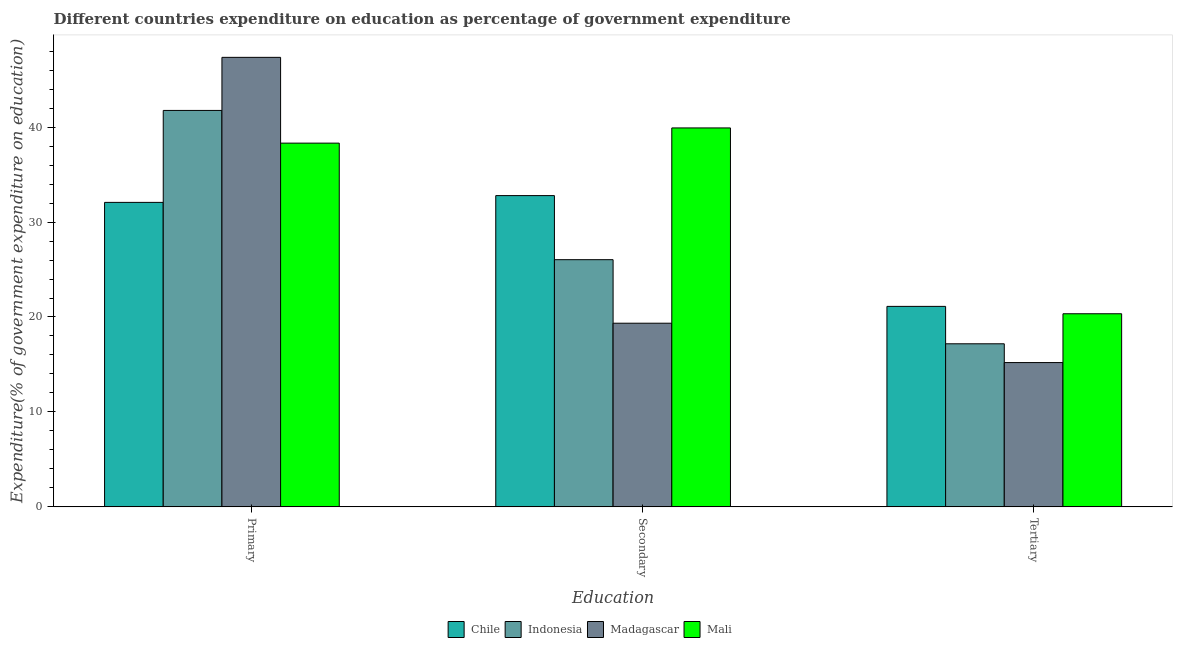How many groups of bars are there?
Give a very brief answer. 3. Are the number of bars per tick equal to the number of legend labels?
Provide a short and direct response. Yes. Are the number of bars on each tick of the X-axis equal?
Provide a succinct answer. Yes. What is the label of the 3rd group of bars from the left?
Your answer should be very brief. Tertiary. What is the expenditure on primary education in Chile?
Offer a very short reply. 32.07. Across all countries, what is the maximum expenditure on tertiary education?
Your answer should be very brief. 21.12. Across all countries, what is the minimum expenditure on secondary education?
Keep it short and to the point. 19.34. In which country was the expenditure on tertiary education minimum?
Your response must be concise. Madagascar. What is the total expenditure on primary education in the graph?
Provide a succinct answer. 159.5. What is the difference between the expenditure on primary education in Mali and that in Madagascar?
Provide a succinct answer. -9.04. What is the difference between the expenditure on primary education in Indonesia and the expenditure on secondary education in Mali?
Make the answer very short. 1.84. What is the average expenditure on primary education per country?
Make the answer very short. 39.88. What is the difference between the expenditure on tertiary education and expenditure on primary education in Madagascar?
Provide a succinct answer. -32.15. In how many countries, is the expenditure on primary education greater than 46 %?
Your answer should be compact. 1. What is the ratio of the expenditure on primary education in Madagascar to that in Indonesia?
Your answer should be compact. 1.13. Is the expenditure on primary education in Madagascar less than that in Indonesia?
Offer a terse response. No. What is the difference between the highest and the second highest expenditure on tertiary education?
Your answer should be very brief. 0.78. What is the difference between the highest and the lowest expenditure on tertiary education?
Provide a succinct answer. 5.92. Is the sum of the expenditure on tertiary education in Chile and Indonesia greater than the maximum expenditure on primary education across all countries?
Ensure brevity in your answer.  No. What does the 3rd bar from the left in Tertiary represents?
Your answer should be compact. Madagascar. What does the 2nd bar from the right in Primary represents?
Offer a very short reply. Madagascar. Is it the case that in every country, the sum of the expenditure on primary education and expenditure on secondary education is greater than the expenditure on tertiary education?
Offer a terse response. Yes. How many bars are there?
Your response must be concise. 12. What is the difference between two consecutive major ticks on the Y-axis?
Offer a very short reply. 10. Are the values on the major ticks of Y-axis written in scientific E-notation?
Make the answer very short. No. Does the graph contain any zero values?
Provide a succinct answer. No. How many legend labels are there?
Your answer should be compact. 4. What is the title of the graph?
Offer a terse response. Different countries expenditure on education as percentage of government expenditure. What is the label or title of the X-axis?
Your answer should be very brief. Education. What is the label or title of the Y-axis?
Provide a succinct answer. Expenditure(% of government expenditure on education). What is the Expenditure(% of government expenditure on education) in Chile in Primary?
Provide a short and direct response. 32.07. What is the Expenditure(% of government expenditure on education) in Indonesia in Primary?
Offer a very short reply. 41.76. What is the Expenditure(% of government expenditure on education) in Madagascar in Primary?
Provide a short and direct response. 47.35. What is the Expenditure(% of government expenditure on education) of Mali in Primary?
Offer a terse response. 38.32. What is the Expenditure(% of government expenditure on education) of Chile in Secondary?
Give a very brief answer. 32.79. What is the Expenditure(% of government expenditure on education) in Indonesia in Secondary?
Your response must be concise. 26.04. What is the Expenditure(% of government expenditure on education) of Madagascar in Secondary?
Keep it short and to the point. 19.34. What is the Expenditure(% of government expenditure on education) in Mali in Secondary?
Offer a very short reply. 39.92. What is the Expenditure(% of government expenditure on education) in Chile in Tertiary?
Your answer should be very brief. 21.12. What is the Expenditure(% of government expenditure on education) of Indonesia in Tertiary?
Your response must be concise. 17.18. What is the Expenditure(% of government expenditure on education) in Madagascar in Tertiary?
Your answer should be compact. 15.2. What is the Expenditure(% of government expenditure on education) of Mali in Tertiary?
Keep it short and to the point. 20.34. Across all Education, what is the maximum Expenditure(% of government expenditure on education) in Chile?
Give a very brief answer. 32.79. Across all Education, what is the maximum Expenditure(% of government expenditure on education) of Indonesia?
Give a very brief answer. 41.76. Across all Education, what is the maximum Expenditure(% of government expenditure on education) of Madagascar?
Keep it short and to the point. 47.35. Across all Education, what is the maximum Expenditure(% of government expenditure on education) of Mali?
Your response must be concise. 39.92. Across all Education, what is the minimum Expenditure(% of government expenditure on education) of Chile?
Make the answer very short. 21.12. Across all Education, what is the minimum Expenditure(% of government expenditure on education) in Indonesia?
Your answer should be very brief. 17.18. Across all Education, what is the minimum Expenditure(% of government expenditure on education) of Madagascar?
Your response must be concise. 15.2. Across all Education, what is the minimum Expenditure(% of government expenditure on education) in Mali?
Your answer should be compact. 20.34. What is the total Expenditure(% of government expenditure on education) of Chile in the graph?
Make the answer very short. 85.98. What is the total Expenditure(% of government expenditure on education) of Indonesia in the graph?
Offer a very short reply. 84.98. What is the total Expenditure(% of government expenditure on education) of Madagascar in the graph?
Give a very brief answer. 81.9. What is the total Expenditure(% of government expenditure on education) of Mali in the graph?
Give a very brief answer. 98.57. What is the difference between the Expenditure(% of government expenditure on education) of Chile in Primary and that in Secondary?
Provide a succinct answer. -0.71. What is the difference between the Expenditure(% of government expenditure on education) of Indonesia in Primary and that in Secondary?
Keep it short and to the point. 15.72. What is the difference between the Expenditure(% of government expenditure on education) in Madagascar in Primary and that in Secondary?
Provide a short and direct response. 28.01. What is the difference between the Expenditure(% of government expenditure on education) in Mali in Primary and that in Secondary?
Offer a terse response. -1.6. What is the difference between the Expenditure(% of government expenditure on education) in Chile in Primary and that in Tertiary?
Your response must be concise. 10.96. What is the difference between the Expenditure(% of government expenditure on education) in Indonesia in Primary and that in Tertiary?
Make the answer very short. 24.58. What is the difference between the Expenditure(% of government expenditure on education) in Madagascar in Primary and that in Tertiary?
Provide a short and direct response. 32.15. What is the difference between the Expenditure(% of government expenditure on education) in Mali in Primary and that in Tertiary?
Your answer should be compact. 17.97. What is the difference between the Expenditure(% of government expenditure on education) of Chile in Secondary and that in Tertiary?
Ensure brevity in your answer.  11.67. What is the difference between the Expenditure(% of government expenditure on education) in Indonesia in Secondary and that in Tertiary?
Offer a terse response. 8.86. What is the difference between the Expenditure(% of government expenditure on education) of Madagascar in Secondary and that in Tertiary?
Provide a short and direct response. 4.15. What is the difference between the Expenditure(% of government expenditure on education) of Mali in Secondary and that in Tertiary?
Your response must be concise. 19.57. What is the difference between the Expenditure(% of government expenditure on education) of Chile in Primary and the Expenditure(% of government expenditure on education) of Indonesia in Secondary?
Provide a short and direct response. 6.04. What is the difference between the Expenditure(% of government expenditure on education) of Chile in Primary and the Expenditure(% of government expenditure on education) of Madagascar in Secondary?
Your answer should be very brief. 12.73. What is the difference between the Expenditure(% of government expenditure on education) in Chile in Primary and the Expenditure(% of government expenditure on education) in Mali in Secondary?
Provide a succinct answer. -7.84. What is the difference between the Expenditure(% of government expenditure on education) of Indonesia in Primary and the Expenditure(% of government expenditure on education) of Madagascar in Secondary?
Provide a succinct answer. 22.42. What is the difference between the Expenditure(% of government expenditure on education) in Indonesia in Primary and the Expenditure(% of government expenditure on education) in Mali in Secondary?
Provide a succinct answer. 1.84. What is the difference between the Expenditure(% of government expenditure on education) in Madagascar in Primary and the Expenditure(% of government expenditure on education) in Mali in Secondary?
Provide a succinct answer. 7.43. What is the difference between the Expenditure(% of government expenditure on education) in Chile in Primary and the Expenditure(% of government expenditure on education) in Indonesia in Tertiary?
Provide a succinct answer. 14.9. What is the difference between the Expenditure(% of government expenditure on education) in Chile in Primary and the Expenditure(% of government expenditure on education) in Madagascar in Tertiary?
Make the answer very short. 16.87. What is the difference between the Expenditure(% of government expenditure on education) in Chile in Primary and the Expenditure(% of government expenditure on education) in Mali in Tertiary?
Keep it short and to the point. 11.73. What is the difference between the Expenditure(% of government expenditure on education) in Indonesia in Primary and the Expenditure(% of government expenditure on education) in Madagascar in Tertiary?
Offer a very short reply. 26.56. What is the difference between the Expenditure(% of government expenditure on education) in Indonesia in Primary and the Expenditure(% of government expenditure on education) in Mali in Tertiary?
Make the answer very short. 21.42. What is the difference between the Expenditure(% of government expenditure on education) in Madagascar in Primary and the Expenditure(% of government expenditure on education) in Mali in Tertiary?
Keep it short and to the point. 27.01. What is the difference between the Expenditure(% of government expenditure on education) in Chile in Secondary and the Expenditure(% of government expenditure on education) in Indonesia in Tertiary?
Give a very brief answer. 15.61. What is the difference between the Expenditure(% of government expenditure on education) in Chile in Secondary and the Expenditure(% of government expenditure on education) in Madagascar in Tertiary?
Ensure brevity in your answer.  17.59. What is the difference between the Expenditure(% of government expenditure on education) in Chile in Secondary and the Expenditure(% of government expenditure on education) in Mali in Tertiary?
Your answer should be very brief. 12.45. What is the difference between the Expenditure(% of government expenditure on education) in Indonesia in Secondary and the Expenditure(% of government expenditure on education) in Madagascar in Tertiary?
Offer a terse response. 10.84. What is the difference between the Expenditure(% of government expenditure on education) in Indonesia in Secondary and the Expenditure(% of government expenditure on education) in Mali in Tertiary?
Keep it short and to the point. 5.7. What is the difference between the Expenditure(% of government expenditure on education) in Madagascar in Secondary and the Expenditure(% of government expenditure on education) in Mali in Tertiary?
Offer a terse response. -1. What is the average Expenditure(% of government expenditure on education) of Chile per Education?
Provide a succinct answer. 28.66. What is the average Expenditure(% of government expenditure on education) of Indonesia per Education?
Keep it short and to the point. 28.33. What is the average Expenditure(% of government expenditure on education) of Madagascar per Education?
Offer a very short reply. 27.3. What is the average Expenditure(% of government expenditure on education) of Mali per Education?
Offer a terse response. 32.86. What is the difference between the Expenditure(% of government expenditure on education) of Chile and Expenditure(% of government expenditure on education) of Indonesia in Primary?
Make the answer very short. -9.69. What is the difference between the Expenditure(% of government expenditure on education) in Chile and Expenditure(% of government expenditure on education) in Madagascar in Primary?
Your answer should be compact. -15.28. What is the difference between the Expenditure(% of government expenditure on education) in Chile and Expenditure(% of government expenditure on education) in Mali in Primary?
Give a very brief answer. -6.24. What is the difference between the Expenditure(% of government expenditure on education) of Indonesia and Expenditure(% of government expenditure on education) of Madagascar in Primary?
Keep it short and to the point. -5.59. What is the difference between the Expenditure(% of government expenditure on education) in Indonesia and Expenditure(% of government expenditure on education) in Mali in Primary?
Make the answer very short. 3.45. What is the difference between the Expenditure(% of government expenditure on education) of Madagascar and Expenditure(% of government expenditure on education) of Mali in Primary?
Make the answer very short. 9.04. What is the difference between the Expenditure(% of government expenditure on education) in Chile and Expenditure(% of government expenditure on education) in Indonesia in Secondary?
Offer a terse response. 6.75. What is the difference between the Expenditure(% of government expenditure on education) in Chile and Expenditure(% of government expenditure on education) in Madagascar in Secondary?
Ensure brevity in your answer.  13.44. What is the difference between the Expenditure(% of government expenditure on education) of Chile and Expenditure(% of government expenditure on education) of Mali in Secondary?
Your answer should be compact. -7.13. What is the difference between the Expenditure(% of government expenditure on education) of Indonesia and Expenditure(% of government expenditure on education) of Madagascar in Secondary?
Offer a terse response. 6.69. What is the difference between the Expenditure(% of government expenditure on education) in Indonesia and Expenditure(% of government expenditure on education) in Mali in Secondary?
Your answer should be very brief. -13.88. What is the difference between the Expenditure(% of government expenditure on education) in Madagascar and Expenditure(% of government expenditure on education) in Mali in Secondary?
Provide a short and direct response. -20.57. What is the difference between the Expenditure(% of government expenditure on education) in Chile and Expenditure(% of government expenditure on education) in Indonesia in Tertiary?
Your answer should be very brief. 3.94. What is the difference between the Expenditure(% of government expenditure on education) of Chile and Expenditure(% of government expenditure on education) of Madagascar in Tertiary?
Your response must be concise. 5.92. What is the difference between the Expenditure(% of government expenditure on education) in Chile and Expenditure(% of government expenditure on education) in Mali in Tertiary?
Your response must be concise. 0.78. What is the difference between the Expenditure(% of government expenditure on education) in Indonesia and Expenditure(% of government expenditure on education) in Madagascar in Tertiary?
Keep it short and to the point. 1.98. What is the difference between the Expenditure(% of government expenditure on education) of Indonesia and Expenditure(% of government expenditure on education) of Mali in Tertiary?
Ensure brevity in your answer.  -3.16. What is the difference between the Expenditure(% of government expenditure on education) of Madagascar and Expenditure(% of government expenditure on education) of Mali in Tertiary?
Offer a very short reply. -5.14. What is the ratio of the Expenditure(% of government expenditure on education) of Chile in Primary to that in Secondary?
Offer a terse response. 0.98. What is the ratio of the Expenditure(% of government expenditure on education) in Indonesia in Primary to that in Secondary?
Keep it short and to the point. 1.6. What is the ratio of the Expenditure(% of government expenditure on education) in Madagascar in Primary to that in Secondary?
Your answer should be very brief. 2.45. What is the ratio of the Expenditure(% of government expenditure on education) of Mali in Primary to that in Secondary?
Keep it short and to the point. 0.96. What is the ratio of the Expenditure(% of government expenditure on education) in Chile in Primary to that in Tertiary?
Give a very brief answer. 1.52. What is the ratio of the Expenditure(% of government expenditure on education) in Indonesia in Primary to that in Tertiary?
Give a very brief answer. 2.43. What is the ratio of the Expenditure(% of government expenditure on education) in Madagascar in Primary to that in Tertiary?
Offer a very short reply. 3.12. What is the ratio of the Expenditure(% of government expenditure on education) in Mali in Primary to that in Tertiary?
Provide a short and direct response. 1.88. What is the ratio of the Expenditure(% of government expenditure on education) in Chile in Secondary to that in Tertiary?
Give a very brief answer. 1.55. What is the ratio of the Expenditure(% of government expenditure on education) of Indonesia in Secondary to that in Tertiary?
Give a very brief answer. 1.52. What is the ratio of the Expenditure(% of government expenditure on education) in Madagascar in Secondary to that in Tertiary?
Make the answer very short. 1.27. What is the ratio of the Expenditure(% of government expenditure on education) of Mali in Secondary to that in Tertiary?
Your response must be concise. 1.96. What is the difference between the highest and the second highest Expenditure(% of government expenditure on education) of Chile?
Your response must be concise. 0.71. What is the difference between the highest and the second highest Expenditure(% of government expenditure on education) of Indonesia?
Keep it short and to the point. 15.72. What is the difference between the highest and the second highest Expenditure(% of government expenditure on education) in Madagascar?
Provide a short and direct response. 28.01. What is the difference between the highest and the second highest Expenditure(% of government expenditure on education) in Mali?
Provide a short and direct response. 1.6. What is the difference between the highest and the lowest Expenditure(% of government expenditure on education) in Chile?
Your answer should be very brief. 11.67. What is the difference between the highest and the lowest Expenditure(% of government expenditure on education) in Indonesia?
Provide a succinct answer. 24.58. What is the difference between the highest and the lowest Expenditure(% of government expenditure on education) of Madagascar?
Your answer should be compact. 32.15. What is the difference between the highest and the lowest Expenditure(% of government expenditure on education) in Mali?
Make the answer very short. 19.57. 